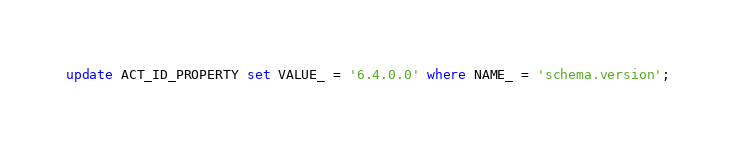Convert code to text. <code><loc_0><loc_0><loc_500><loc_500><_SQL_>update ACT_ID_PROPERTY set VALUE_ = '6.4.0.0' where NAME_ = 'schema.version';
</code> 